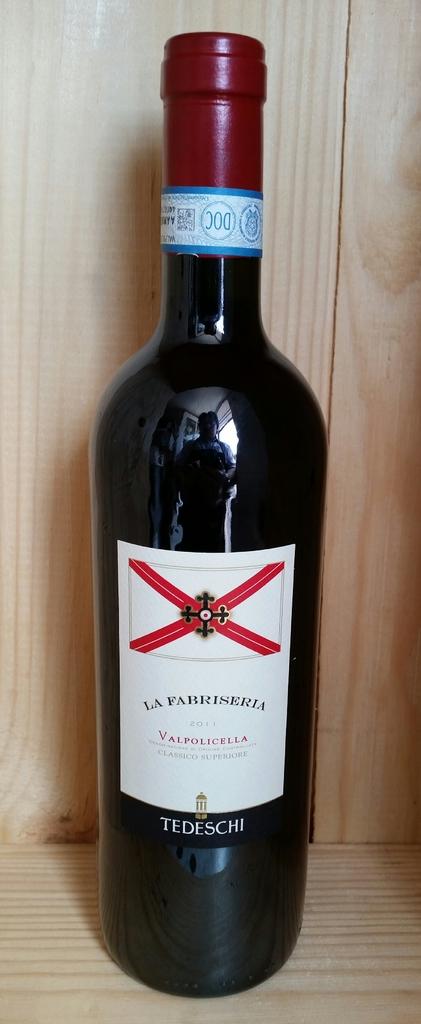Is there a red x on the bottle?
Your answer should be compact. Yes. 